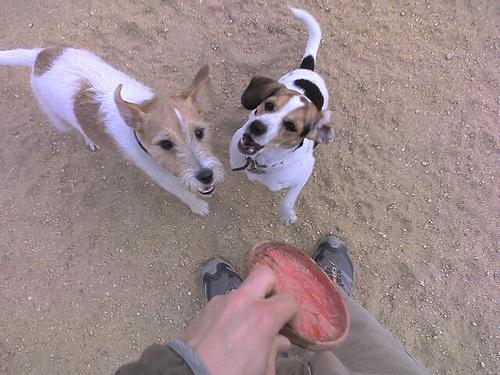Describe the dogs in the image and their actions. A white and black dog, and a white and brown dog with unique ears are looking at the man, while one of them is jumping up. Describe the characteristics of the two dogs in the image. One dog has dark brown ears, black spots, and a black nose, while the other has light brown ears and spots with white paws. Briefly narrate the scenario of the image in a single sentence. A man holding a frisbee catches the attention of two dogs with different colored ears on a dirt ground with pebbles. Summarize the scene depicted in the image. Two dogs with different colored ears are playing near a man who's holding a red frisbee, surrounded by dirt and small pebbles. What is the primary interaction happening between the subject/s in the image? The two dogs with varied ears are staring at the man holding a red frisbee, engaging with him. State the key details of the scene in the image. The image shows two dogs with distinct ears, a man holding a red frisbee, and a dirt ground with small pebbles scattered around. What is the man holding, and how is he dressed? The man holds a red disc and is dressed in a brown jacket, grey pants, and black shoes. Mention the key elements observed in the image. There are two dogs with distinct ears, a man with a red frisbee, and dirt with small pebbles. In a single sentence, express the main subjects and the setting of the image. Two dogs with differently-colored ears and a man with a red frisbee interact on a dirt ground full of small pebbles. Explain the primary event taking place in the image. Two dogs with varied ears are playing on the dirt as a man holds a red frisbee, surrounded by small pebbles. 